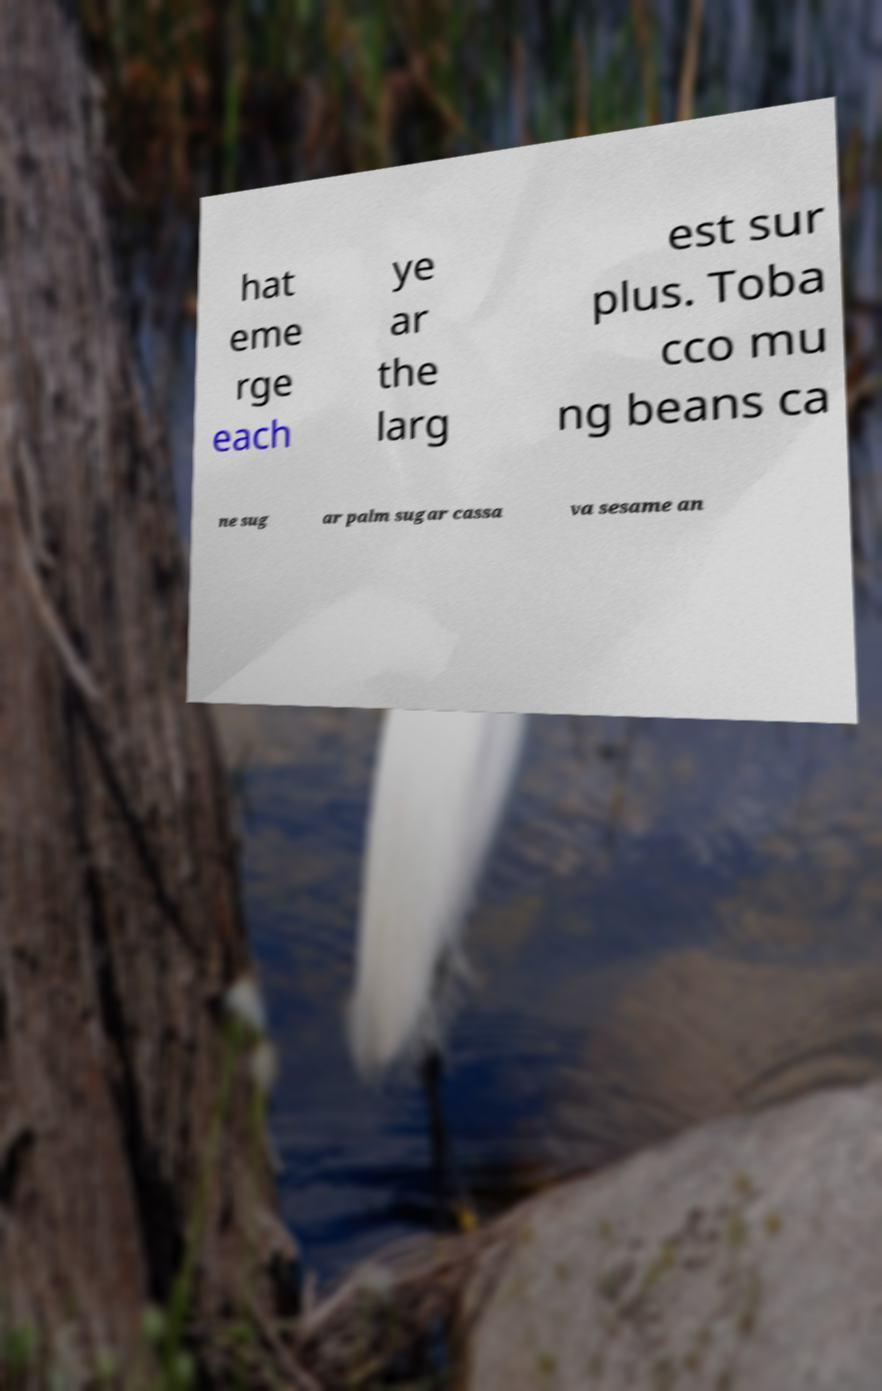Please identify and transcribe the text found in this image. hat eme rge each ye ar the larg est sur plus. Toba cco mu ng beans ca ne sug ar palm sugar cassa va sesame an 